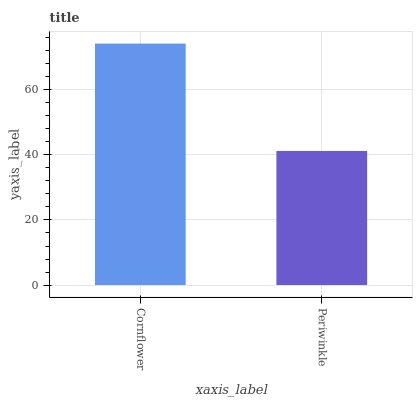Is Periwinkle the minimum?
Answer yes or no. Yes. Is Cornflower the maximum?
Answer yes or no. Yes. Is Periwinkle the maximum?
Answer yes or no. No. Is Cornflower greater than Periwinkle?
Answer yes or no. Yes. Is Periwinkle less than Cornflower?
Answer yes or no. Yes. Is Periwinkle greater than Cornflower?
Answer yes or no. No. Is Cornflower less than Periwinkle?
Answer yes or no. No. Is Cornflower the high median?
Answer yes or no. Yes. Is Periwinkle the low median?
Answer yes or no. Yes. Is Periwinkle the high median?
Answer yes or no. No. Is Cornflower the low median?
Answer yes or no. No. 